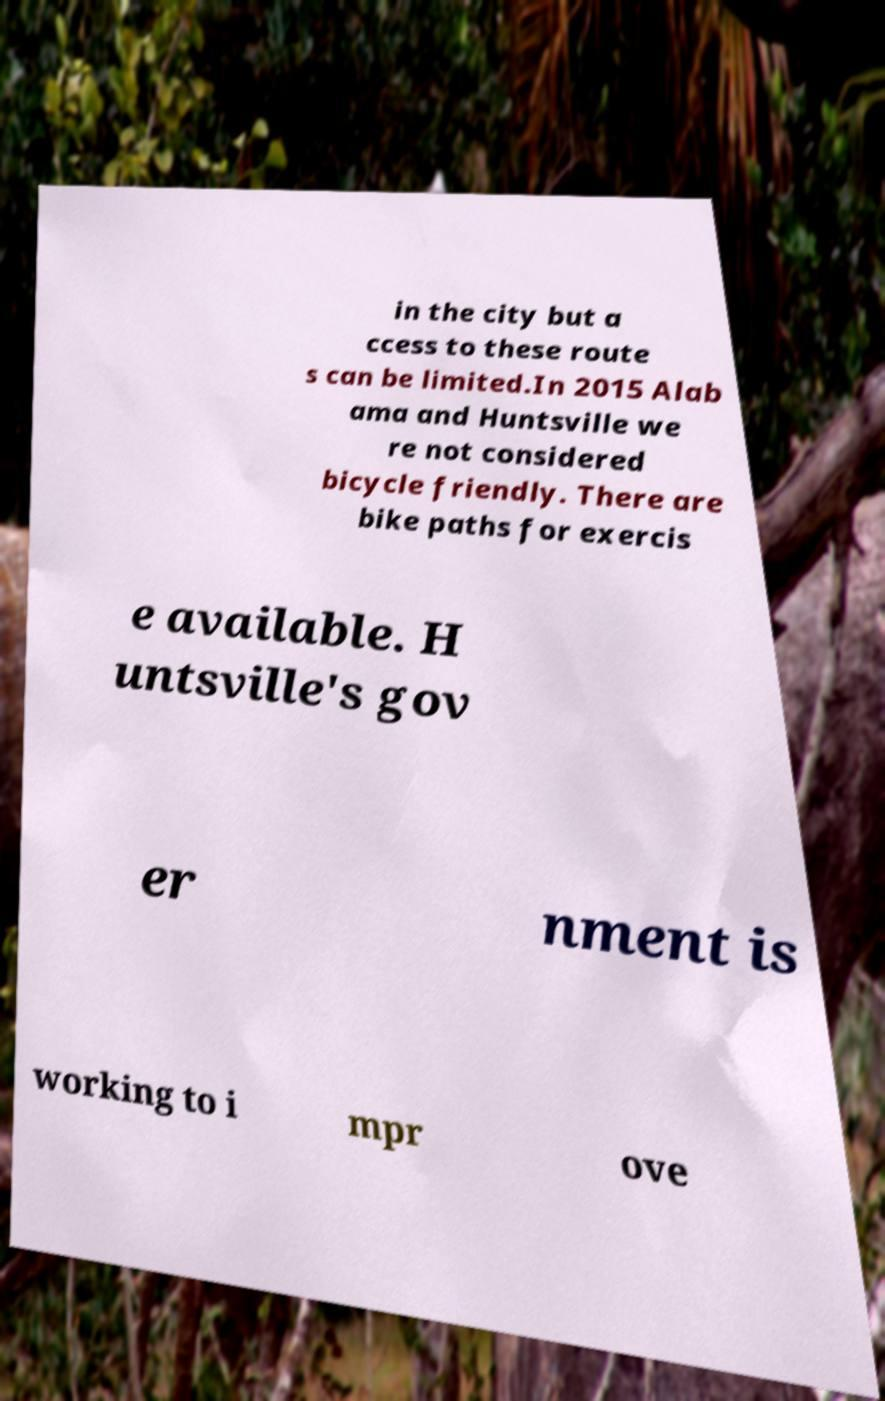What messages or text are displayed in this image? I need them in a readable, typed format. in the city but a ccess to these route s can be limited.In 2015 Alab ama and Huntsville we re not considered bicycle friendly. There are bike paths for exercis e available. H untsville's gov er nment is working to i mpr ove 